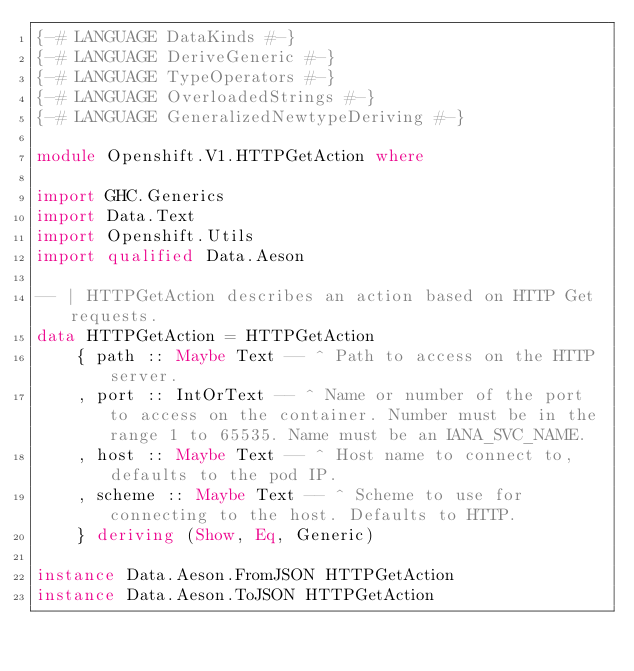Convert code to text. <code><loc_0><loc_0><loc_500><loc_500><_Haskell_>{-# LANGUAGE DataKinds #-}
{-# LANGUAGE DeriveGeneric #-}
{-# LANGUAGE TypeOperators #-}
{-# LANGUAGE OverloadedStrings #-}
{-# LANGUAGE GeneralizedNewtypeDeriving #-}

module Openshift.V1.HTTPGetAction where

import GHC.Generics
import Data.Text
import Openshift.Utils
import qualified Data.Aeson

-- | HTTPGetAction describes an action based on HTTP Get requests.
data HTTPGetAction = HTTPGetAction
    { path :: Maybe Text -- ^ Path to access on the HTTP server. 
    , port :: IntOrText -- ^ Name or number of the port to access on the container. Number must be in the range 1 to 65535. Name must be an IANA_SVC_NAME. 
    , host :: Maybe Text -- ^ Host name to connect to, defaults to the pod IP. 
    , scheme :: Maybe Text -- ^ Scheme to use for connecting to the host. Defaults to HTTP. 
    } deriving (Show, Eq, Generic)

instance Data.Aeson.FromJSON HTTPGetAction
instance Data.Aeson.ToJSON HTTPGetAction
</code> 